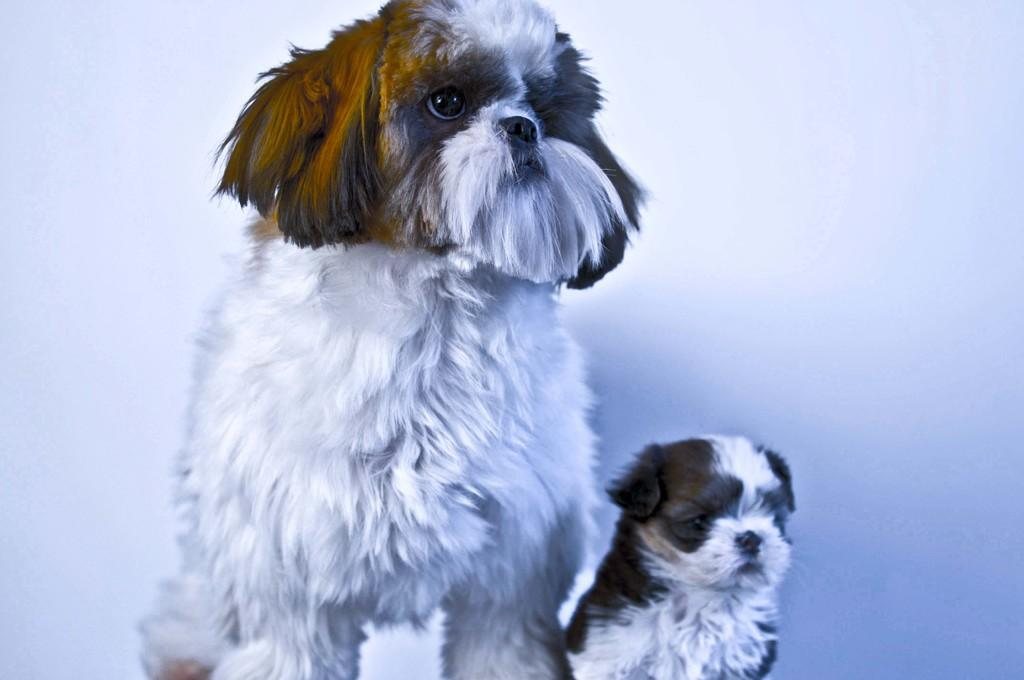What type of animals are present in the image? There are dogs in the image. What type of farmer is depicted in the image? There is no farmer present in the image; it only features dogs. What type of hydrant can be seen in the image? There is no hydrant present in the image; it only features dogs. 